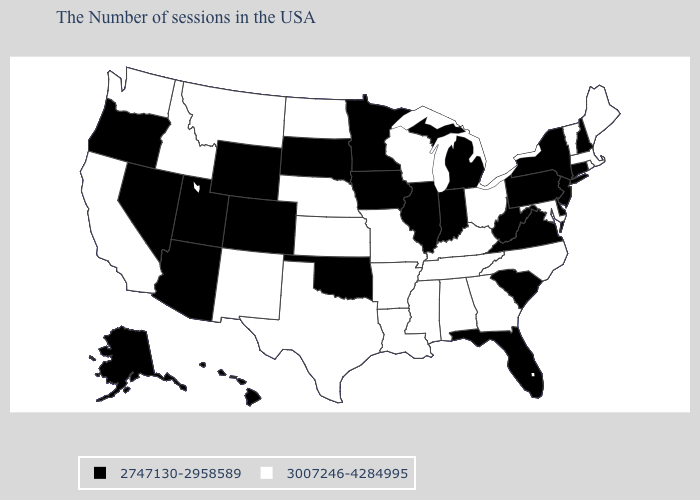What is the value of Illinois?
Quick response, please. 2747130-2958589. Does Maryland have the lowest value in the USA?
Give a very brief answer. No. Does Idaho have the same value as Georgia?
Write a very short answer. Yes. Which states hav the highest value in the South?
Write a very short answer. Maryland, North Carolina, Georgia, Kentucky, Alabama, Tennessee, Mississippi, Louisiana, Arkansas, Texas. What is the value of Nebraska?
Short answer required. 3007246-4284995. What is the lowest value in states that border Kentucky?
Concise answer only. 2747130-2958589. What is the highest value in the South ?
Write a very short answer. 3007246-4284995. What is the highest value in the MidWest ?
Concise answer only. 3007246-4284995. Is the legend a continuous bar?
Short answer required. No. What is the lowest value in the USA?
Concise answer only. 2747130-2958589. Name the states that have a value in the range 2747130-2958589?
Write a very short answer. New Hampshire, Connecticut, New York, New Jersey, Delaware, Pennsylvania, Virginia, South Carolina, West Virginia, Florida, Michigan, Indiana, Illinois, Minnesota, Iowa, Oklahoma, South Dakota, Wyoming, Colorado, Utah, Arizona, Nevada, Oregon, Alaska, Hawaii. How many symbols are there in the legend?
Short answer required. 2. What is the value of Washington?
Keep it brief. 3007246-4284995. Name the states that have a value in the range 2747130-2958589?
Concise answer only. New Hampshire, Connecticut, New York, New Jersey, Delaware, Pennsylvania, Virginia, South Carolina, West Virginia, Florida, Michigan, Indiana, Illinois, Minnesota, Iowa, Oklahoma, South Dakota, Wyoming, Colorado, Utah, Arizona, Nevada, Oregon, Alaska, Hawaii. Name the states that have a value in the range 3007246-4284995?
Give a very brief answer. Maine, Massachusetts, Rhode Island, Vermont, Maryland, North Carolina, Ohio, Georgia, Kentucky, Alabama, Tennessee, Wisconsin, Mississippi, Louisiana, Missouri, Arkansas, Kansas, Nebraska, Texas, North Dakota, New Mexico, Montana, Idaho, California, Washington. 